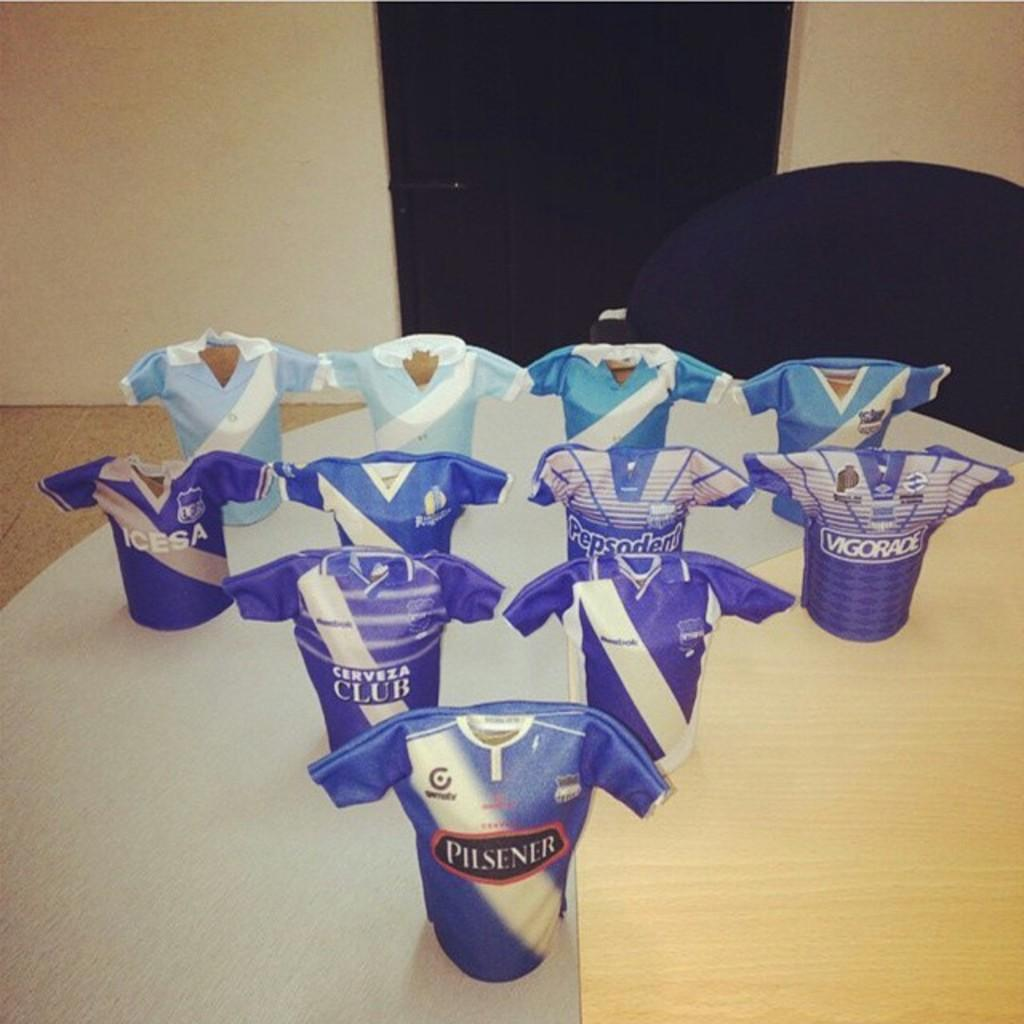<image>
Render a clear and concise summary of the photo. a pilsenar jersey that is purple and also white 